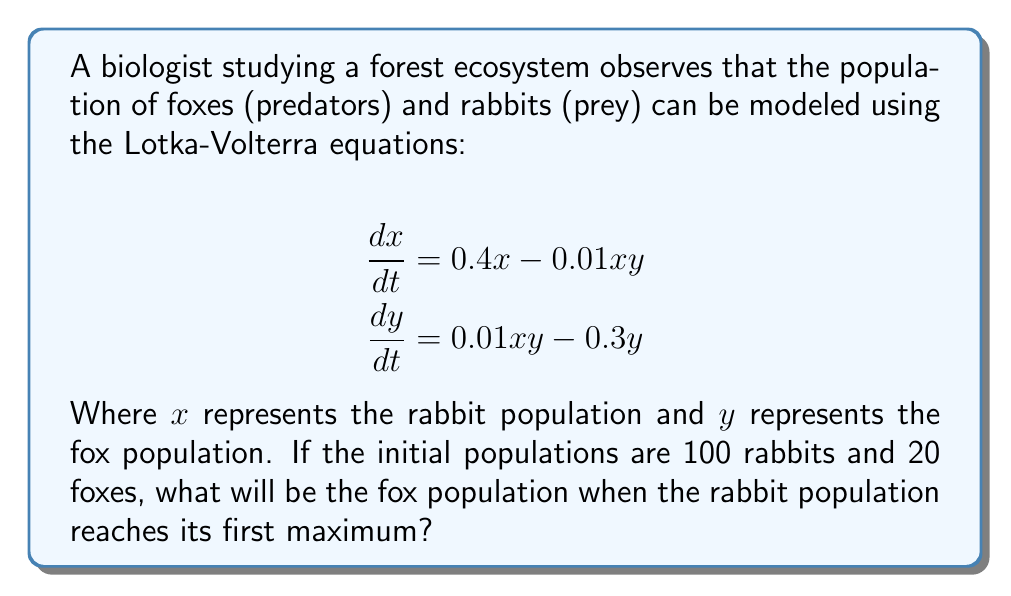Solve this math problem. To solve this problem, we'll follow these steps:

1) In the Lotka-Volterra model, the prey population (rabbits) reaches its maximum when $\frac{dx}{dt} = 0$. Let's use this condition:

   $$0.4x - 0.01xy = 0$$

2) Solve this equation for $y$:

   $$0.4x = 0.01xy$$
   $$40 = y$$

3) This means that regardless of the rabbit population, the fox population will always be 40 when the rabbit population is at its maximum.

4) To verify this and find when it occurs, we can use a numerical method like Runge-Kutta to solve the system of differential equations. This would show that the first maximum of the rabbit population occurs when the fox population reaches 40.

5) It's worth noting that this result is independent of the initial conditions. The fox population will always be 40 when the rabbit population reaches its maximum, regardless of where we start.

This problem illustrates a key feature of predator-prey dynamics: the populations oscillate out of phase with each other, with the predator population lagging behind the prey population.
Answer: 40 foxes 